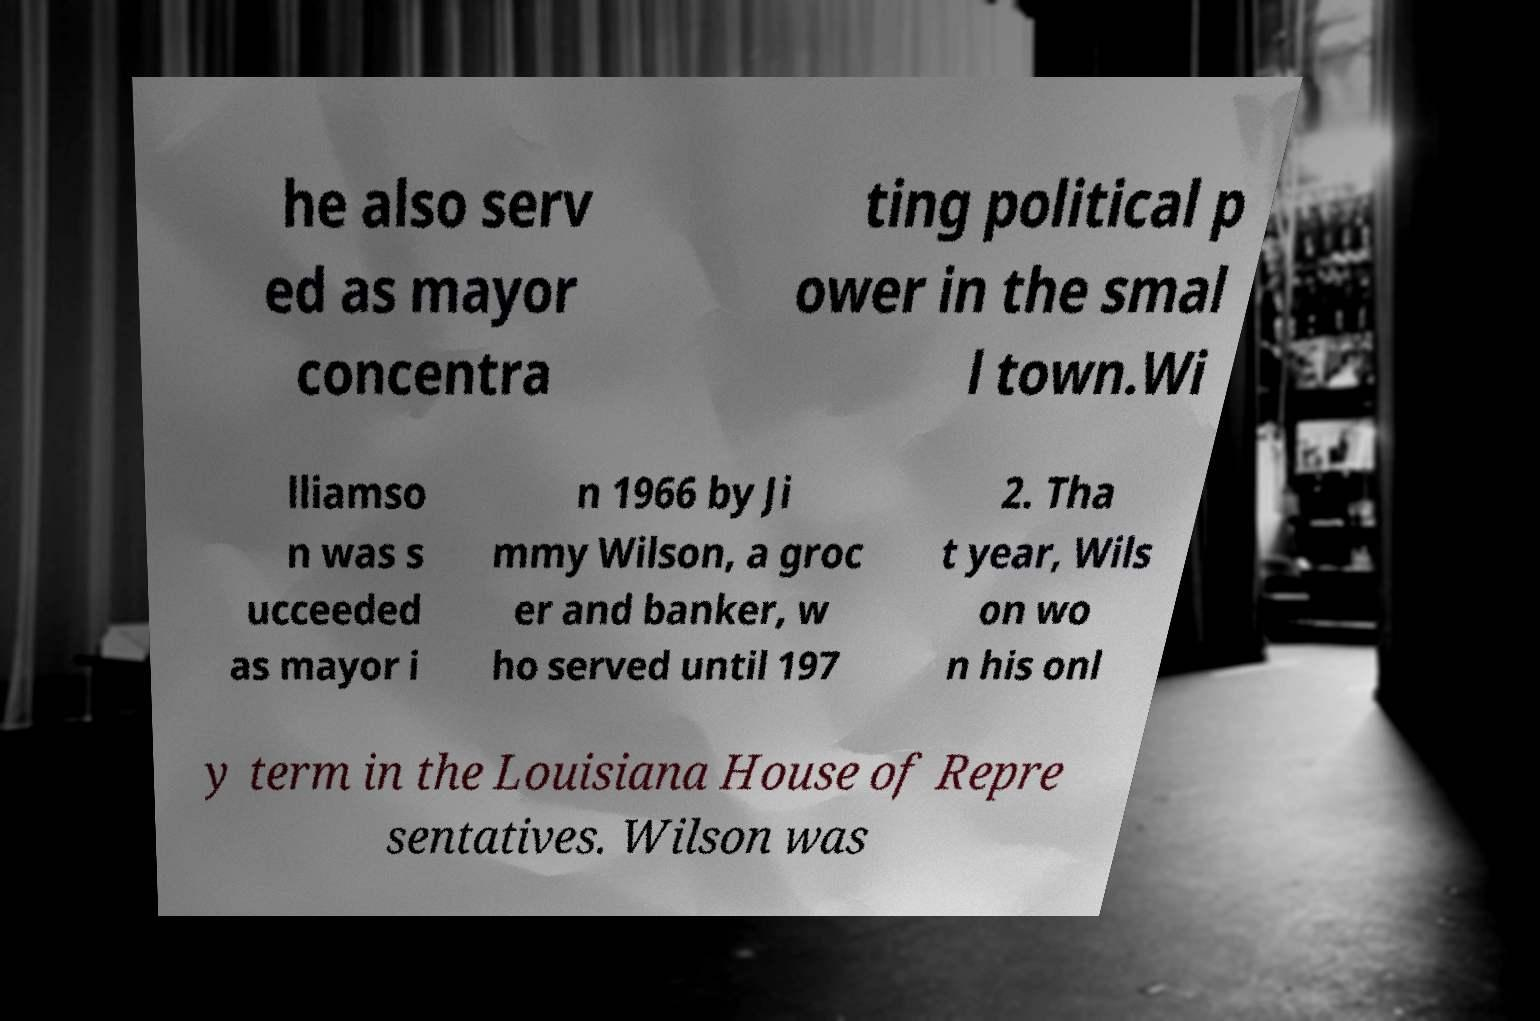What messages or text are displayed in this image? I need them in a readable, typed format. he also serv ed as mayor concentra ting political p ower in the smal l town.Wi lliamso n was s ucceeded as mayor i n 1966 by Ji mmy Wilson, a groc er and banker, w ho served until 197 2. Tha t year, Wils on wo n his onl y term in the Louisiana House of Repre sentatives. Wilson was 